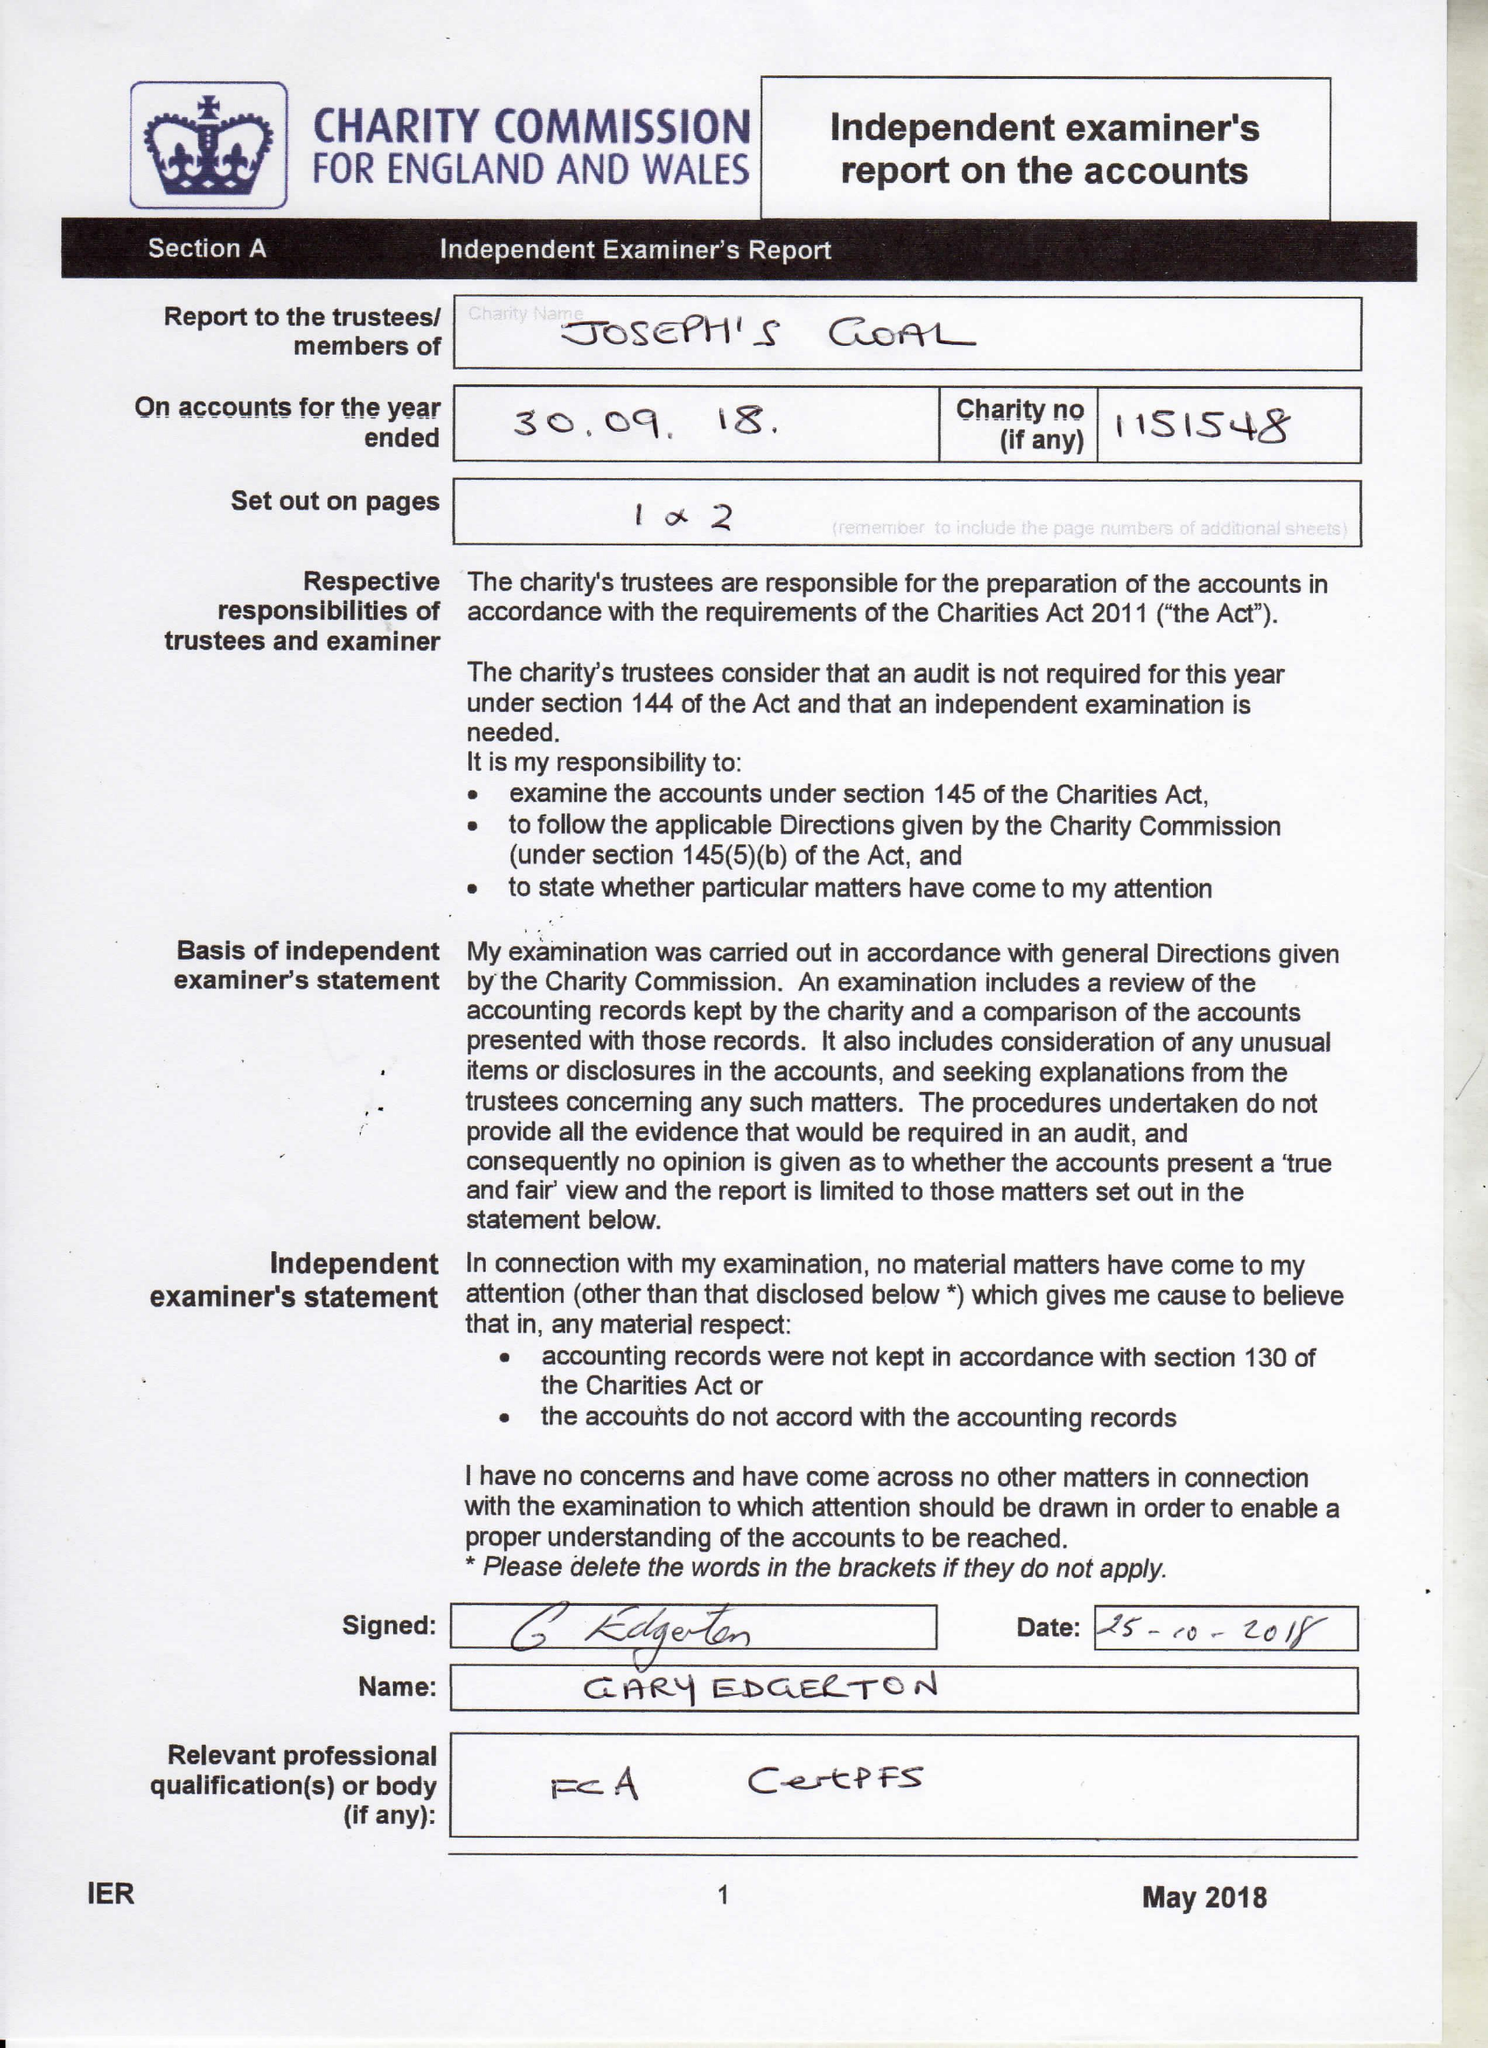What is the value for the report_date?
Answer the question using a single word or phrase. 2018-09-30 